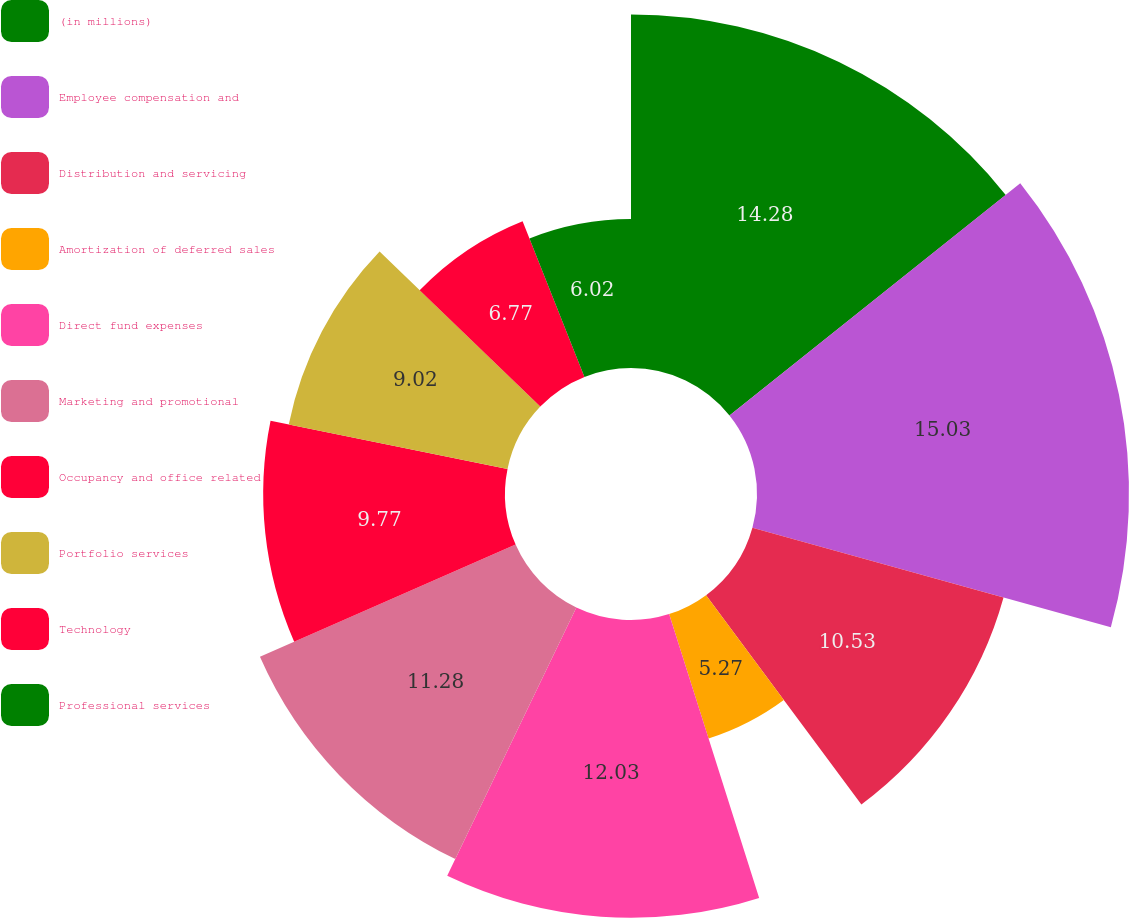Convert chart. <chart><loc_0><loc_0><loc_500><loc_500><pie_chart><fcel>(in millions)<fcel>Employee compensation and<fcel>Distribution and servicing<fcel>Amortization of deferred sales<fcel>Direct fund expenses<fcel>Marketing and promotional<fcel>Occupancy and office related<fcel>Portfolio services<fcel>Technology<fcel>Professional services<nl><fcel>14.28%<fcel>15.03%<fcel>10.53%<fcel>5.27%<fcel>12.03%<fcel>11.28%<fcel>9.77%<fcel>9.02%<fcel>6.77%<fcel>6.02%<nl></chart> 